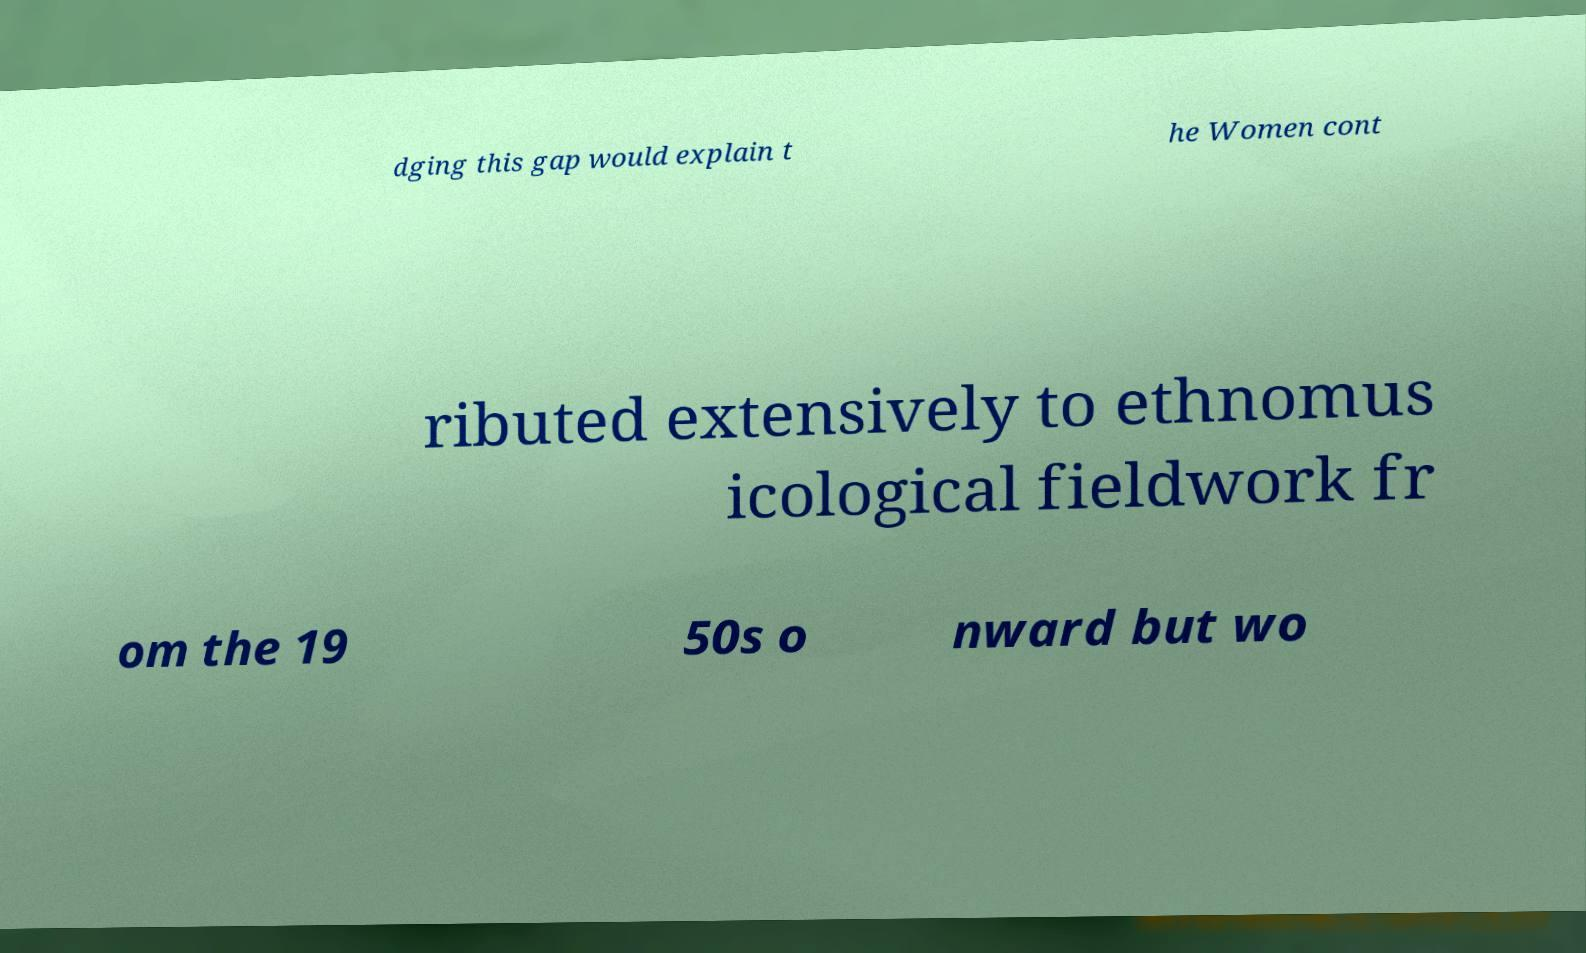Please identify and transcribe the text found in this image. dging this gap would explain t he Women cont ributed extensively to ethnomus icological fieldwork fr om the 19 50s o nward but wo 